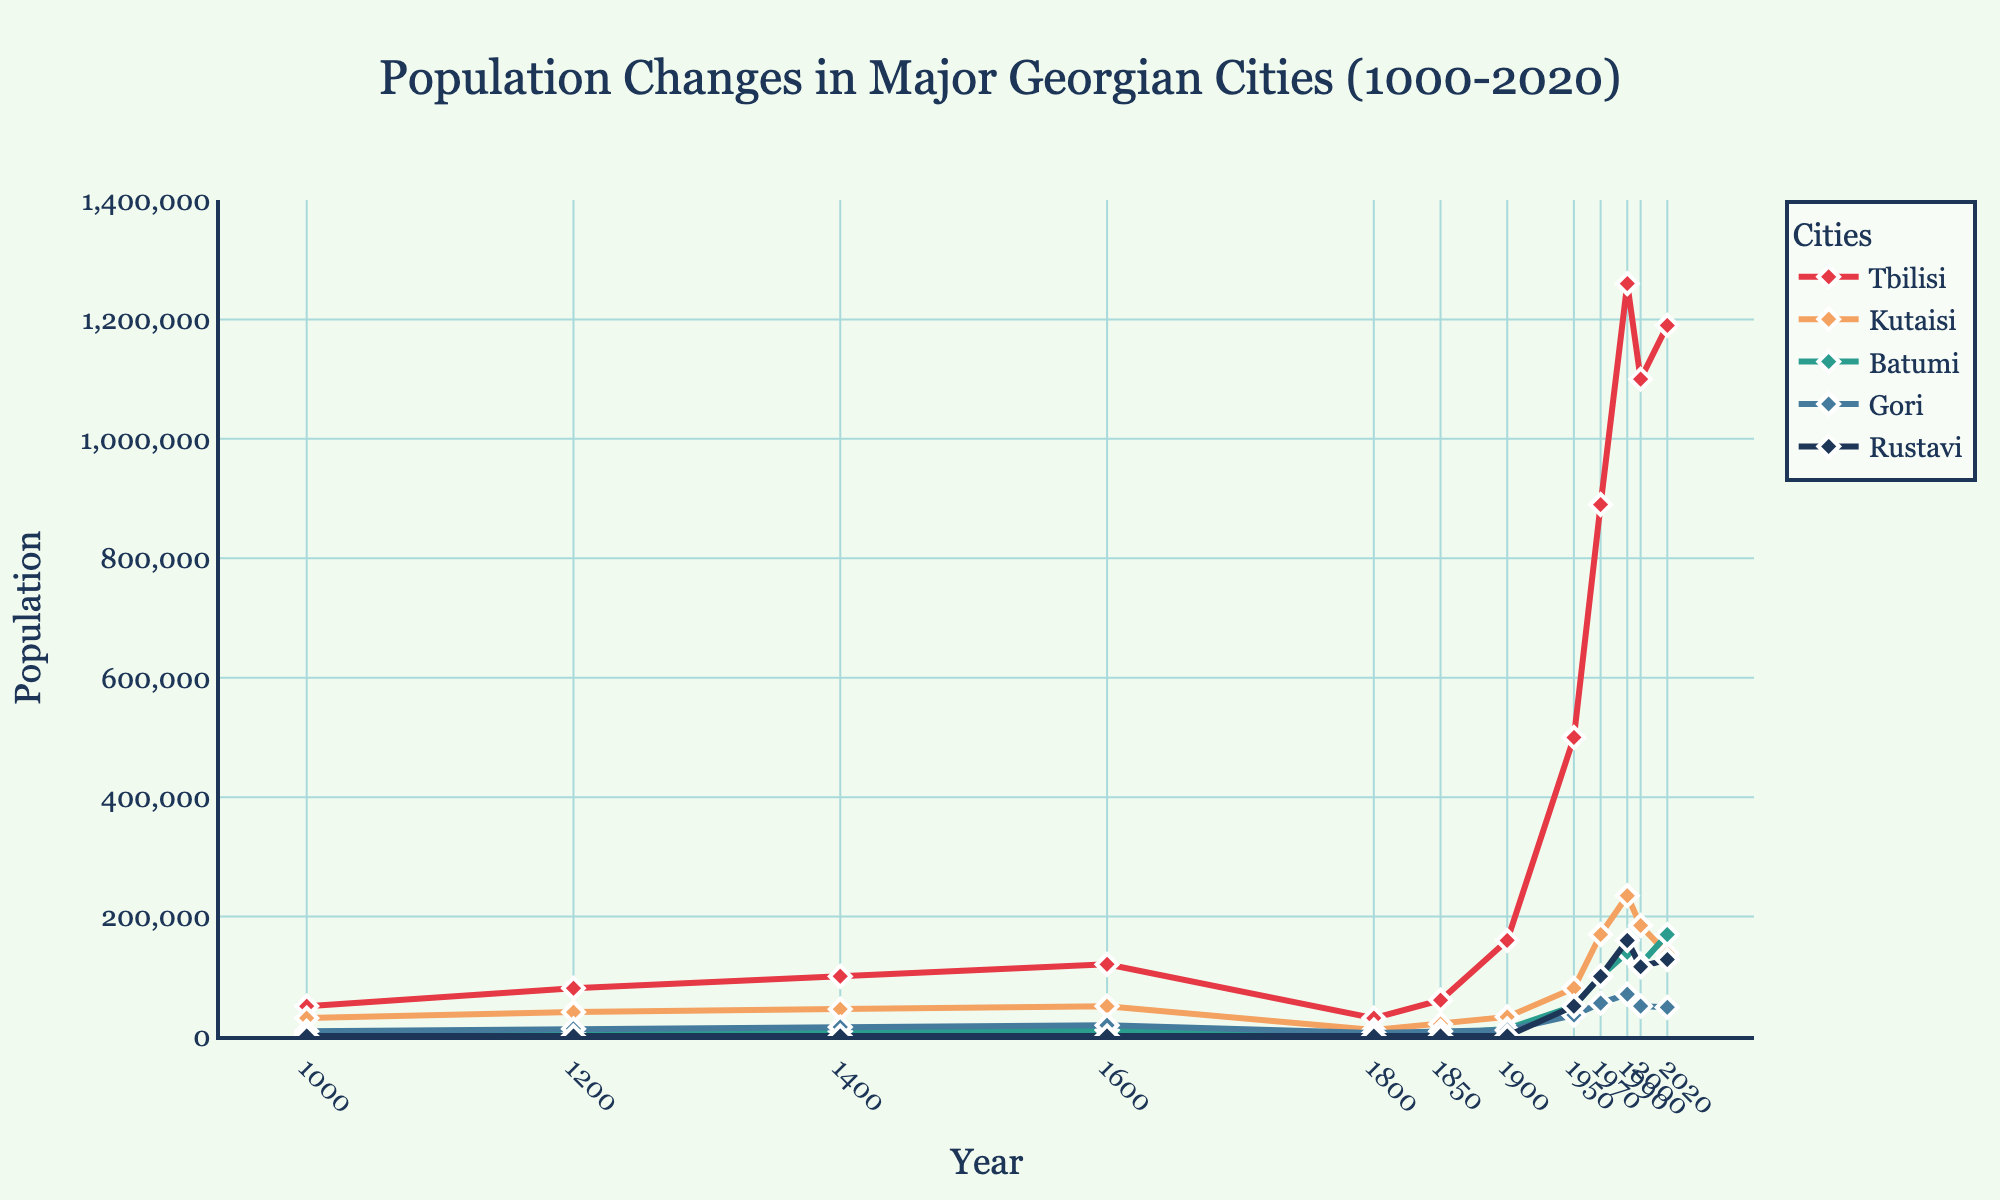What is the highest population recorded for Tbilisi? The figure shows the population changes for Tbilisi from 1000 to 2020. The highest point on Tbilisi's line corresponds to the year 1990. The population here is marked as 1,260,000.
Answer: 1,260,000 Which city had the greatest population drop between two consecutive years, and when did it occur? By examining the figure and noting the lines' steepness, the greatest drop is in Tbilisi between 1990 to 2000. The population decreases from 1,260,000 to 1,100,000, a drop of 160,000.
Answer: Tbilisi, from 1990 to 2000 In what year did Batumi's population surpass 100,000? Batumi's line crosses the 100,000 mark between the years 1950 and 1970. Upon closer inspection, it surpasses 100,000 in the year 1970.
Answer: 1970 Compare the populations of Rustavi and Kutaisi in the year 2020. Which city has a higher population, and by how much? In 2020, Kutaisi has a population of 138,000 while Rustavi's population is 128,000. The difference is 138,000 - 128,000 = 10,000.
Answer: Kutaisi, by 10,000 How many cities started with a zero population in the year 1000? From the data, the only city with a population documented as zero in the year 1000 is Rustavi. The other cities have non-zero populations.
Answer: 1 Which city had the smallest population in the year 1800, and what is the value? In 1800, the populations are displayed as follows: Tbilisi (30,000), Kutaisi (10,000), Batumi (2,000), Gori (5,000), and Rustavi (0). Batumi has the smallest non-zero population, which is 2,000.
Answer: Batumi, 2,000 In what year did Rustavi's population first reach or exceed 100,000? Rustavi's population line crosses the 100,000 mark between 1950 and 1970. It reaches 100,000 in the year 1970.
Answer: 1970 Calculate the average population of Kutaisi across all documented years. The sums of populations for Kutaisi are 30000+40000+45000+50000+10000+20000+32000+80000+170000+235000+185000+138000 = 1021000. There are 12 data points, so the average is 1021000 / 12.
Answer: 85,083 Which city exhibited the most stable population trend over the years, and why? By observing the lines' smoothness and minimal fluctuations, Gori has the least variation compared to other cities. Its population changes are relatively small and gradual without abrupt increases or decreases.
Answer: Gori By how much did the population of Batumi increase from 1850 to 2020? In 1850, Batumi's population was 3,000. In 2020, it was 170,000. The increase is 170,000 - 3,000 = 167,000.
Answer: 167,000 